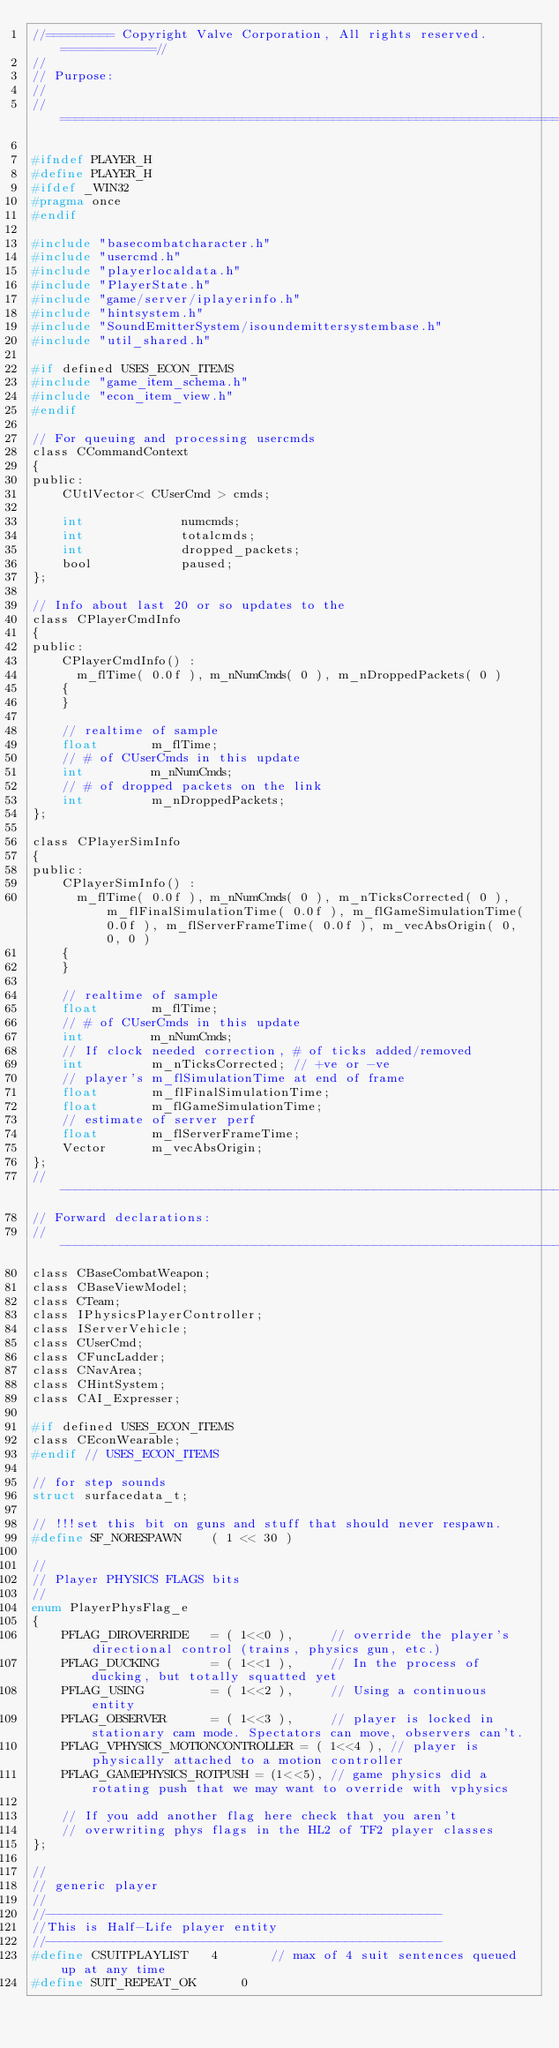Convert code to text. <code><loc_0><loc_0><loc_500><loc_500><_C_>//========= Copyright Valve Corporation, All rights reserved. ============//
//
// Purpose: 
//
//===========================================================================//

#ifndef PLAYER_H
#define PLAYER_H
#ifdef _WIN32
#pragma once
#endif

#include "basecombatcharacter.h"
#include "usercmd.h"
#include "playerlocaldata.h"
#include "PlayerState.h"
#include "game/server/iplayerinfo.h"
#include "hintsystem.h"
#include "SoundEmitterSystem/isoundemittersystembase.h"
#include "util_shared.h"

#if defined USES_ECON_ITEMS
#include "game_item_schema.h"
#include "econ_item_view.h"
#endif

// For queuing and processing usercmds
class CCommandContext
{
public:
	CUtlVector< CUserCmd > cmds;

	int				numcmds;
	int				totalcmds;
	int				dropped_packets;
	bool			paused;
};

// Info about last 20 or so updates to the
class CPlayerCmdInfo
{
public:
	CPlayerCmdInfo() : 
	  m_flTime( 0.0f ), m_nNumCmds( 0 ), m_nDroppedPackets( 0 )
	{
	}

	// realtime of sample
	float		m_flTime;
	// # of CUserCmds in this update
	int			m_nNumCmds;
	// # of dropped packets on the link
	int			m_nDroppedPackets;
};

class CPlayerSimInfo
{
public:
	CPlayerSimInfo() : 
	  m_flTime( 0.0f ), m_nNumCmds( 0 ), m_nTicksCorrected( 0 ), m_flFinalSimulationTime( 0.0f ), m_flGameSimulationTime( 0.0f ), m_flServerFrameTime( 0.0f ), m_vecAbsOrigin( 0, 0, 0 )
	{
	}

	// realtime of sample
	float		m_flTime;
	// # of CUserCmds in this update
	int			m_nNumCmds;
	// If clock needed correction, # of ticks added/removed
	int			m_nTicksCorrected; // +ve or -ve
	// player's m_flSimulationTime at end of frame
	float		m_flFinalSimulationTime;
	float		m_flGameSimulationTime;
	// estimate of server perf
	float		m_flServerFrameTime;  
	Vector		m_vecAbsOrigin;
};
//-----------------------------------------------------------------------------
// Forward declarations: 
//-----------------------------------------------------------------------------
class CBaseCombatWeapon;
class CBaseViewModel;
class CTeam;
class IPhysicsPlayerController;
class IServerVehicle;
class CUserCmd;
class CFuncLadder;
class CNavArea;
class CHintSystem;
class CAI_Expresser;

#if defined USES_ECON_ITEMS
class CEconWearable;
#endif // USES_ECON_ITEMS

// for step sounds
struct surfacedata_t;

// !!!set this bit on guns and stuff that should never respawn.
#define	SF_NORESPAWN	( 1 << 30 )

//
// Player PHYSICS FLAGS bits
//
enum PlayerPhysFlag_e
{
	PFLAG_DIROVERRIDE	= ( 1<<0 ),		// override the player's directional control (trains, physics gun, etc.)
	PFLAG_DUCKING		= ( 1<<1 ),		// In the process of ducking, but totally squatted yet
	PFLAG_USING			= ( 1<<2 ),		// Using a continuous entity
	PFLAG_OBSERVER		= ( 1<<3 ),		// player is locked in stationary cam mode. Spectators can move, observers can't.
	PFLAG_VPHYSICS_MOTIONCONTROLLER = ( 1<<4 ),	// player is physically attached to a motion controller
	PFLAG_GAMEPHYSICS_ROTPUSH = (1<<5), // game physics did a rotating push that we may want to override with vphysics

	// If you add another flag here check that you aren't 
	// overwriting phys flags in the HL2 of TF2 player classes
};

//
// generic player
//
//-----------------------------------------------------
//This is Half-Life player entity
//-----------------------------------------------------
#define CSUITPLAYLIST	4		// max of 4 suit sentences queued up at any time
#define	SUIT_REPEAT_OK		0
</code> 